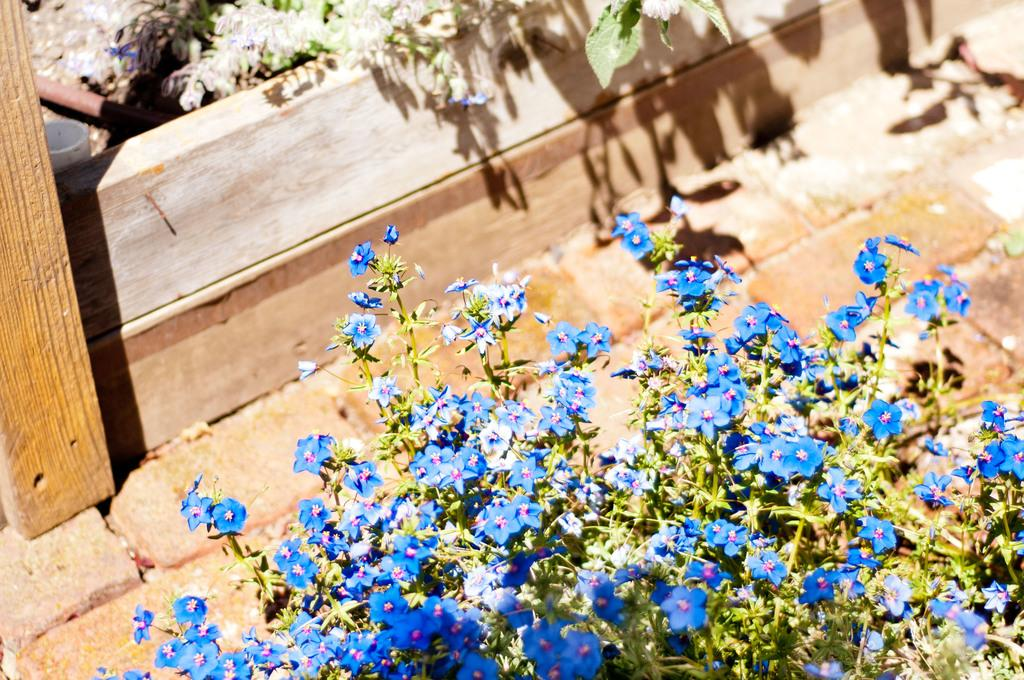What type of living organisms are present in the image? There are plants in the image. What specific feature can be observed on the plants? The plants have flowers. What color are the flowers on the plants? The flowers are blue in color. What material is used for the planks in the image? The planks in the image are made of wood. What verse can be heard recited by the plants in the image? There are no verses or sounds associated with the plants in the image; they are silent and inanimate. Is there a net visible in the image? There is no net present in the image. 